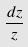Convert formula to latex. <formula><loc_0><loc_0><loc_500><loc_500>\frac { d z } { z }</formula> 